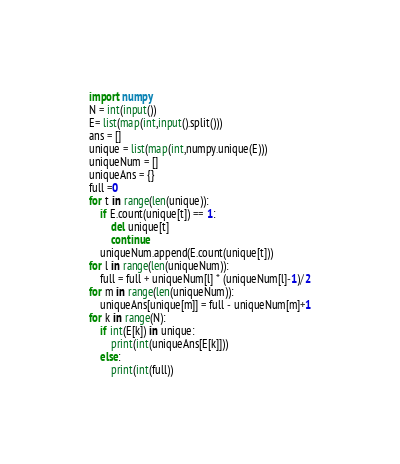<code> <loc_0><loc_0><loc_500><loc_500><_Python_>import numpy
N = int(input())
E= list(map(int,input().split()))
ans = []
unique = list(map(int,numpy.unique(E)))
uniqueNum = []
uniqueAns = {}
full =0
for t in range(len(unique)):
    if E.count(unique[t]) == 1:
        del unique[t]
        continue
    uniqueNum.append(E.count(unique[t]))
for l in range(len(uniqueNum)):
    full = full + uniqueNum[l] * (uniqueNum[l]-1)/2
for m in range(len(uniqueNum)):
    uniqueAns[unique[m]] = full - uniqueNum[m]+1
for k in range(N):
    if int(E[k]) in unique:
        print(int(uniqueAns[E[k]]))
    else:
        print(int(full))    </code> 